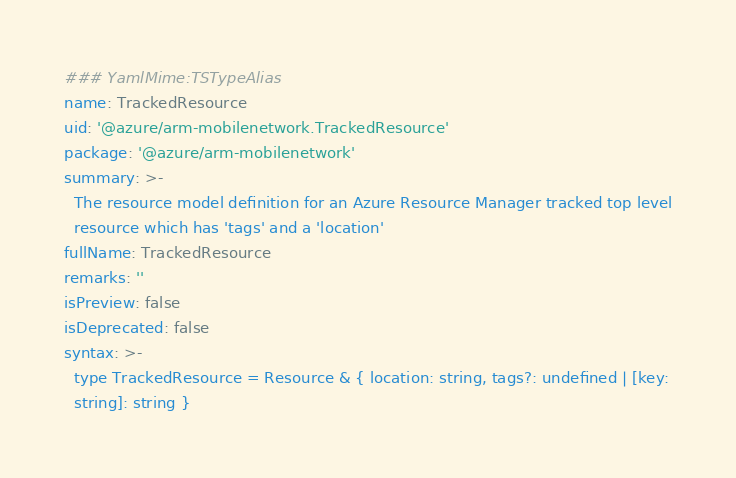Convert code to text. <code><loc_0><loc_0><loc_500><loc_500><_YAML_>### YamlMime:TSTypeAlias
name: TrackedResource
uid: '@azure/arm-mobilenetwork.TrackedResource'
package: '@azure/arm-mobilenetwork'
summary: >-
  The resource model definition for an Azure Resource Manager tracked top level
  resource which has 'tags' and a 'location'
fullName: TrackedResource
remarks: ''
isPreview: false
isDeprecated: false
syntax: >-
  type TrackedResource = Resource & { location: string, tags?: undefined | [key:
  string]: string }
</code> 